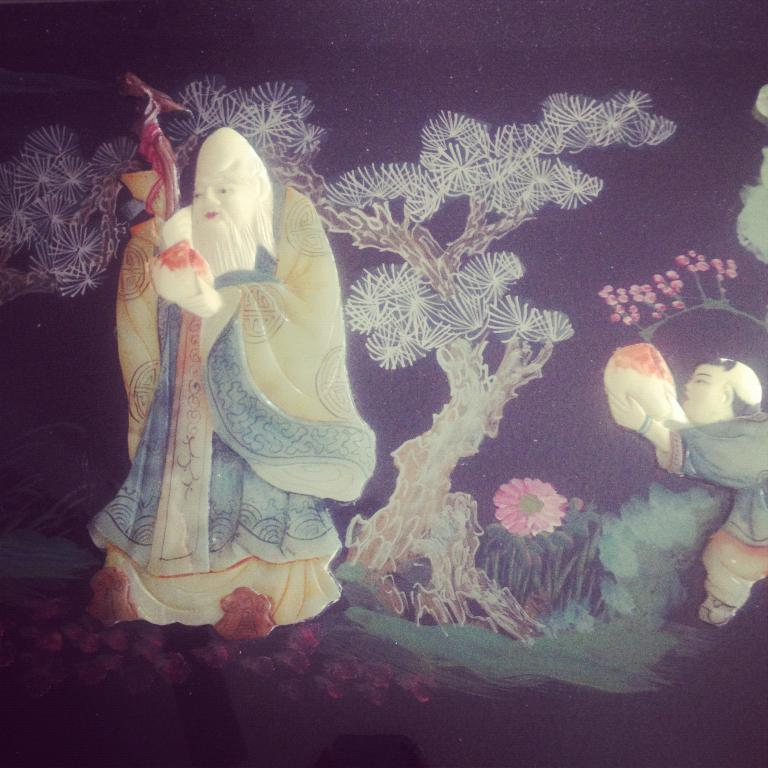What is the main subject of the image? There is a painting in the image. What does the painting depict? The painting depicts an old person, specifically a woman. What natural elements are present in the painting? There are trees, plants, and flowers in the painting. How does the disgust in the painting compare to the disgust in a different painting? There is no mention of disgust in the image or the painting, so it cannot be compared to another painting. 